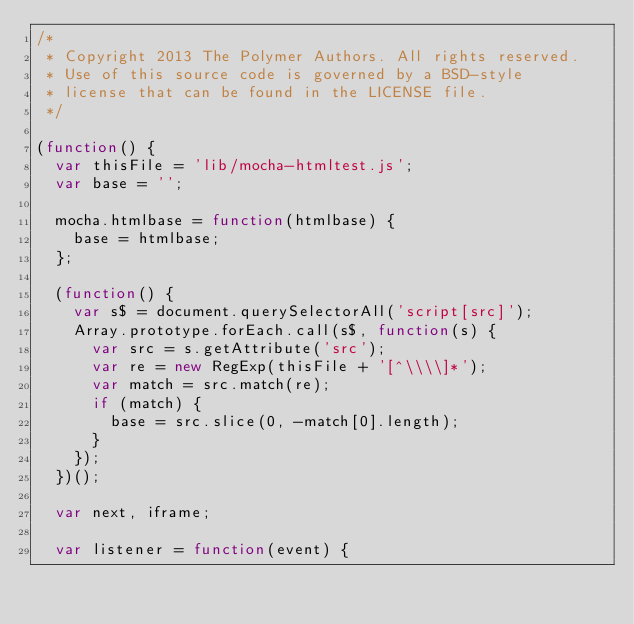<code> <loc_0><loc_0><loc_500><loc_500><_JavaScript_>/*
 * Copyright 2013 The Polymer Authors. All rights reserved.
 * Use of this source code is governed by a BSD-style
 * license that can be found in the LICENSE file.
 */

(function() {
  var thisFile = 'lib/mocha-htmltest.js';
  var base = '';

  mocha.htmlbase = function(htmlbase) {
    base = htmlbase;
  };

  (function() {
    var s$ = document.querySelectorAll('script[src]');
    Array.prototype.forEach.call(s$, function(s) {
      var src = s.getAttribute('src');
      var re = new RegExp(thisFile + '[^\\\\]*');
      var match = src.match(re);
      if (match) {
        base = src.slice(0, -match[0].length);
      }
    });
  })();

  var next, iframe;

  var listener = function(event) {</code> 